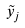Convert formula to latex. <formula><loc_0><loc_0><loc_500><loc_500>\tilde { y } _ { j }</formula> 